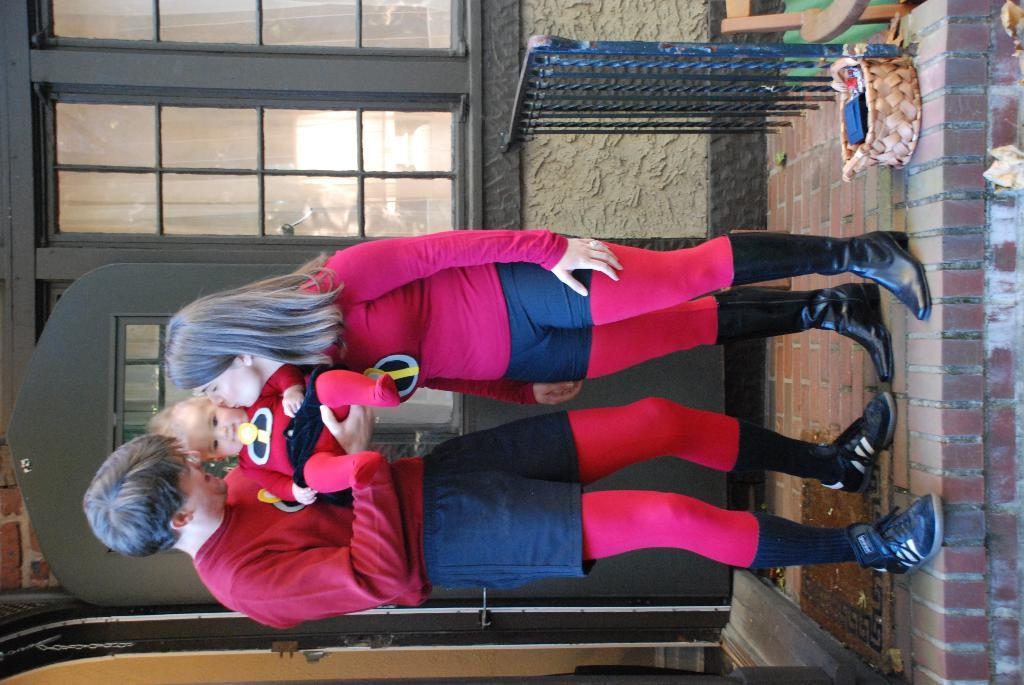How many people are in the image? There are two people in the image. What are the two people doing? The two people are standing and holding a baby. What can be seen on the right side of the image? There are many bricks on the right side of the image. What type of robin can be seen perched on the hill in the image? There is no robin or hill present in the image. 